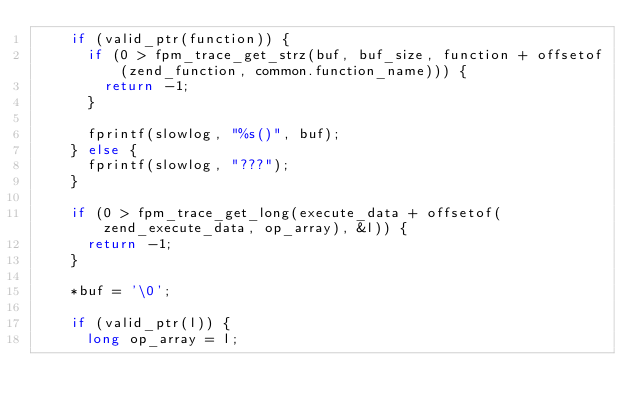<code> <loc_0><loc_0><loc_500><loc_500><_C_>		if (valid_ptr(function)) {
			if (0 > fpm_trace_get_strz(buf, buf_size, function + offsetof(zend_function, common.function_name))) {
				return -1;
			}

			fprintf(slowlog, "%s()", buf);
		} else {
			fprintf(slowlog, "???");
		}

		if (0 > fpm_trace_get_long(execute_data + offsetof(zend_execute_data, op_array), &l)) {
			return -1;
		}

		*buf = '\0';

		if (valid_ptr(l)) {
			long op_array = l;
</code> 